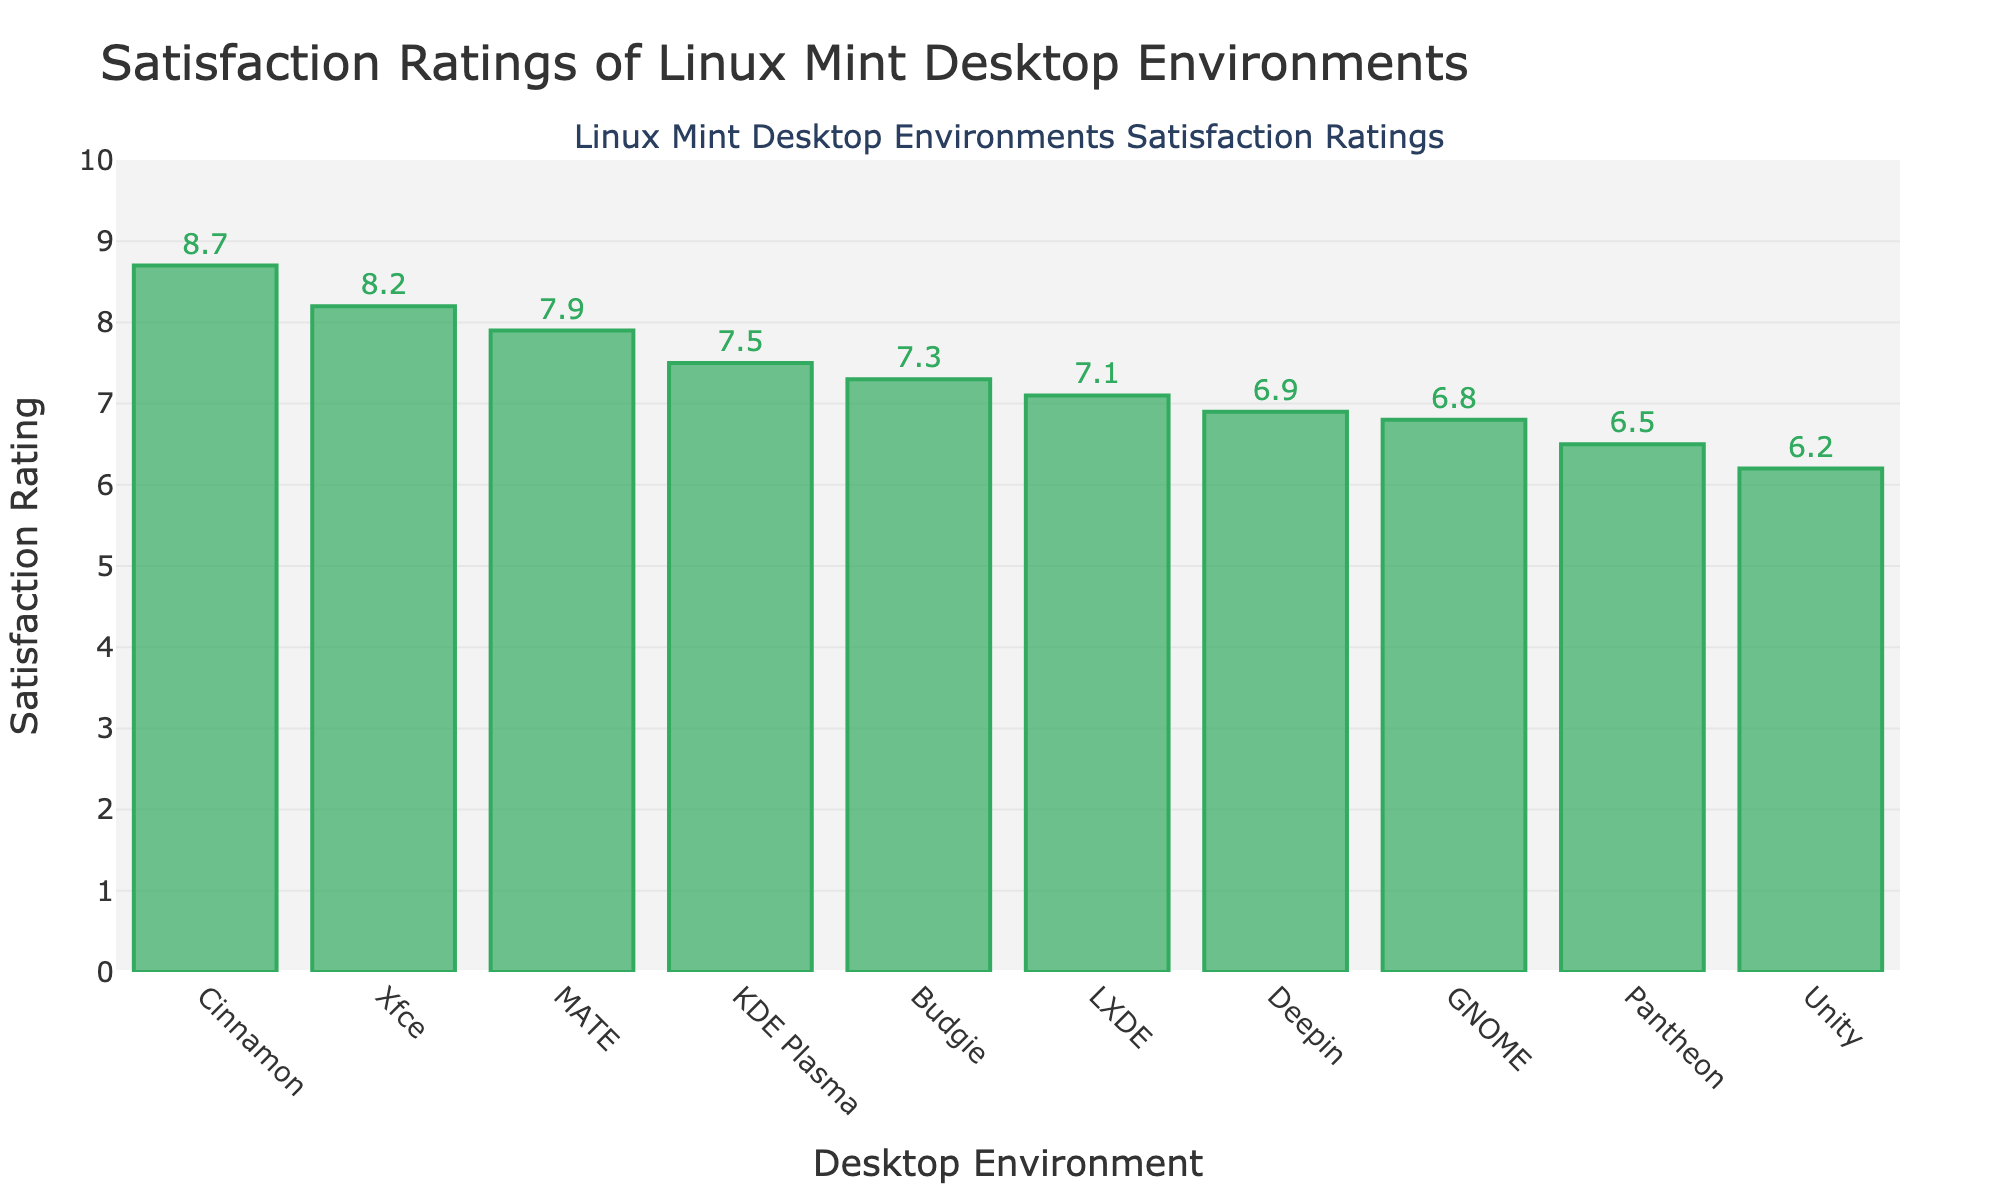What's the highest satisfaction rating among the desktop environments? Look at the bar that reaches the highest on the y-axis. It is labeled with a value of 8.7 for Cinnamon.
Answer: 8.7 What is the difference in satisfaction ratings between Cinnamon and GNOME? The satisfaction rating for Cinnamon is 8.7 and for GNOME is 6.8. Subtract GNOME's rating from Cinnamon’s rating: 8.7 - 6.8.
Answer: 1.9 Which desktop environment has the second highest satisfaction rating? First, identify the highest bar (Cinnamon at 8.7). The second highest bar is Xfce at 8.2.
Answer: Xfce How many desktop environments have a satisfaction rating greater than 7.5? Identify bars with ratings exceeding 7.5: Cinnamon (8.7), MATE (7.9), Xfce (8.2). There are three.
Answer: 3 What are the average satisfaction ratings of KDE Plasma, LXDE, and Budgie? Add their ratings: 7.5 (KDE Plasma) + 7.1 (LXDE) + 7.3 (Budgie) = 21.9. Divide by the number of environments (3).
Answer: 7.3 Which desktop environment has the lowest satisfaction rating? Look for the shortest bar on the y-axis. The bar for Unity is the shortest with a rating of 6.2.
Answer: Unity Is the satisfaction rating of LXDE higher or lower than that of GNOME? Compare the heights of their bars. LXDE is 7.1 and GNOME is 6.8. LXDE's rating is higher.
Answer: Higher What is the combined satisfaction rating of the three least satisfying desktop environments? Add the three lowest ratings: Pantheon (6.5) + Unity (6.2) + GNOME (6.8).
Answer: 19.5 Are there more desktop environments with satisfaction ratings above or below 7? Count bars above and below 7. Above 7: 5 (Cinnamon, MATE, Xfce, LXDE, Budgie). Below 7: 5 (KDE Plasma, GNOME, Unity, Pantheon, Deepin). The counts are equal.
Answer: Equal 